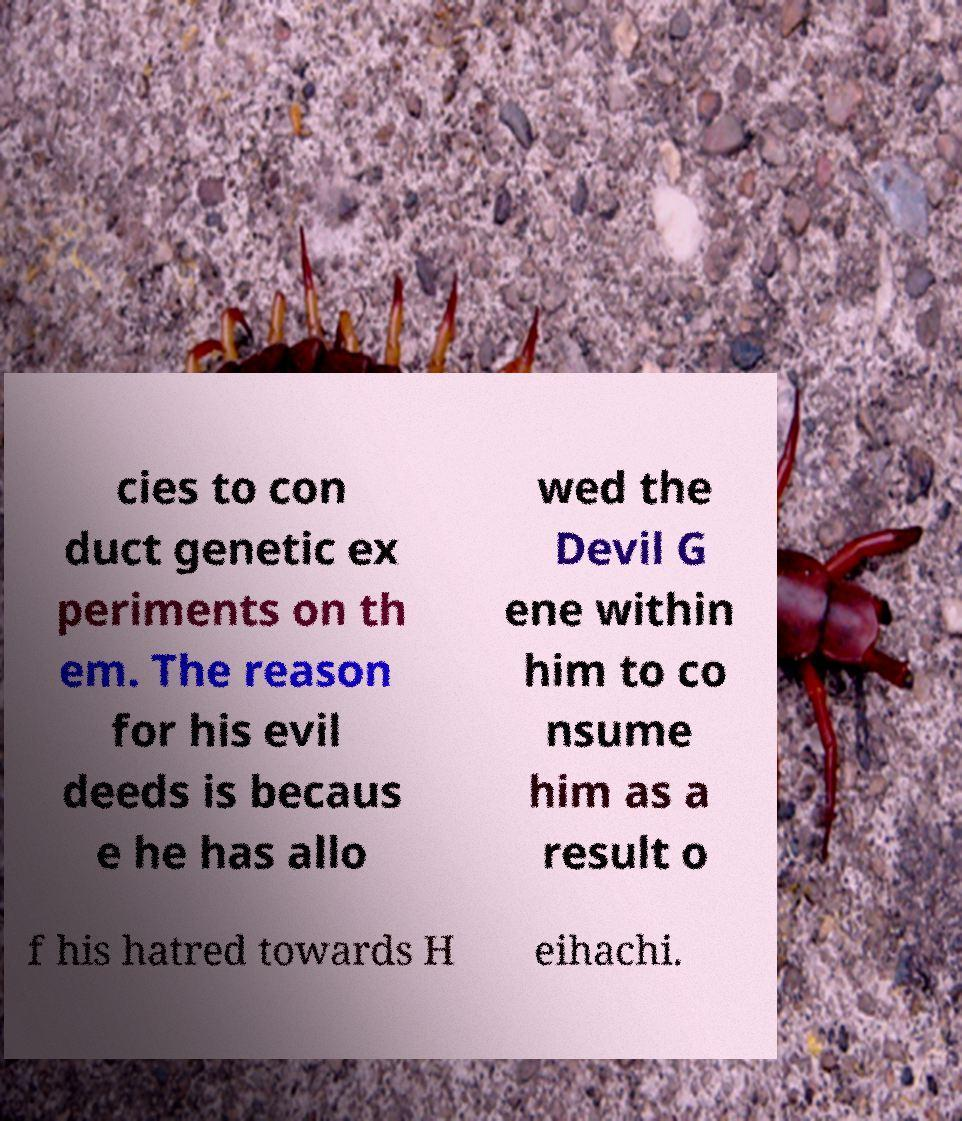Can you accurately transcribe the text from the provided image for me? cies to con duct genetic ex periments on th em. The reason for his evil deeds is becaus e he has allo wed the Devil G ene within him to co nsume him as a result o f his hatred towards H eihachi. 